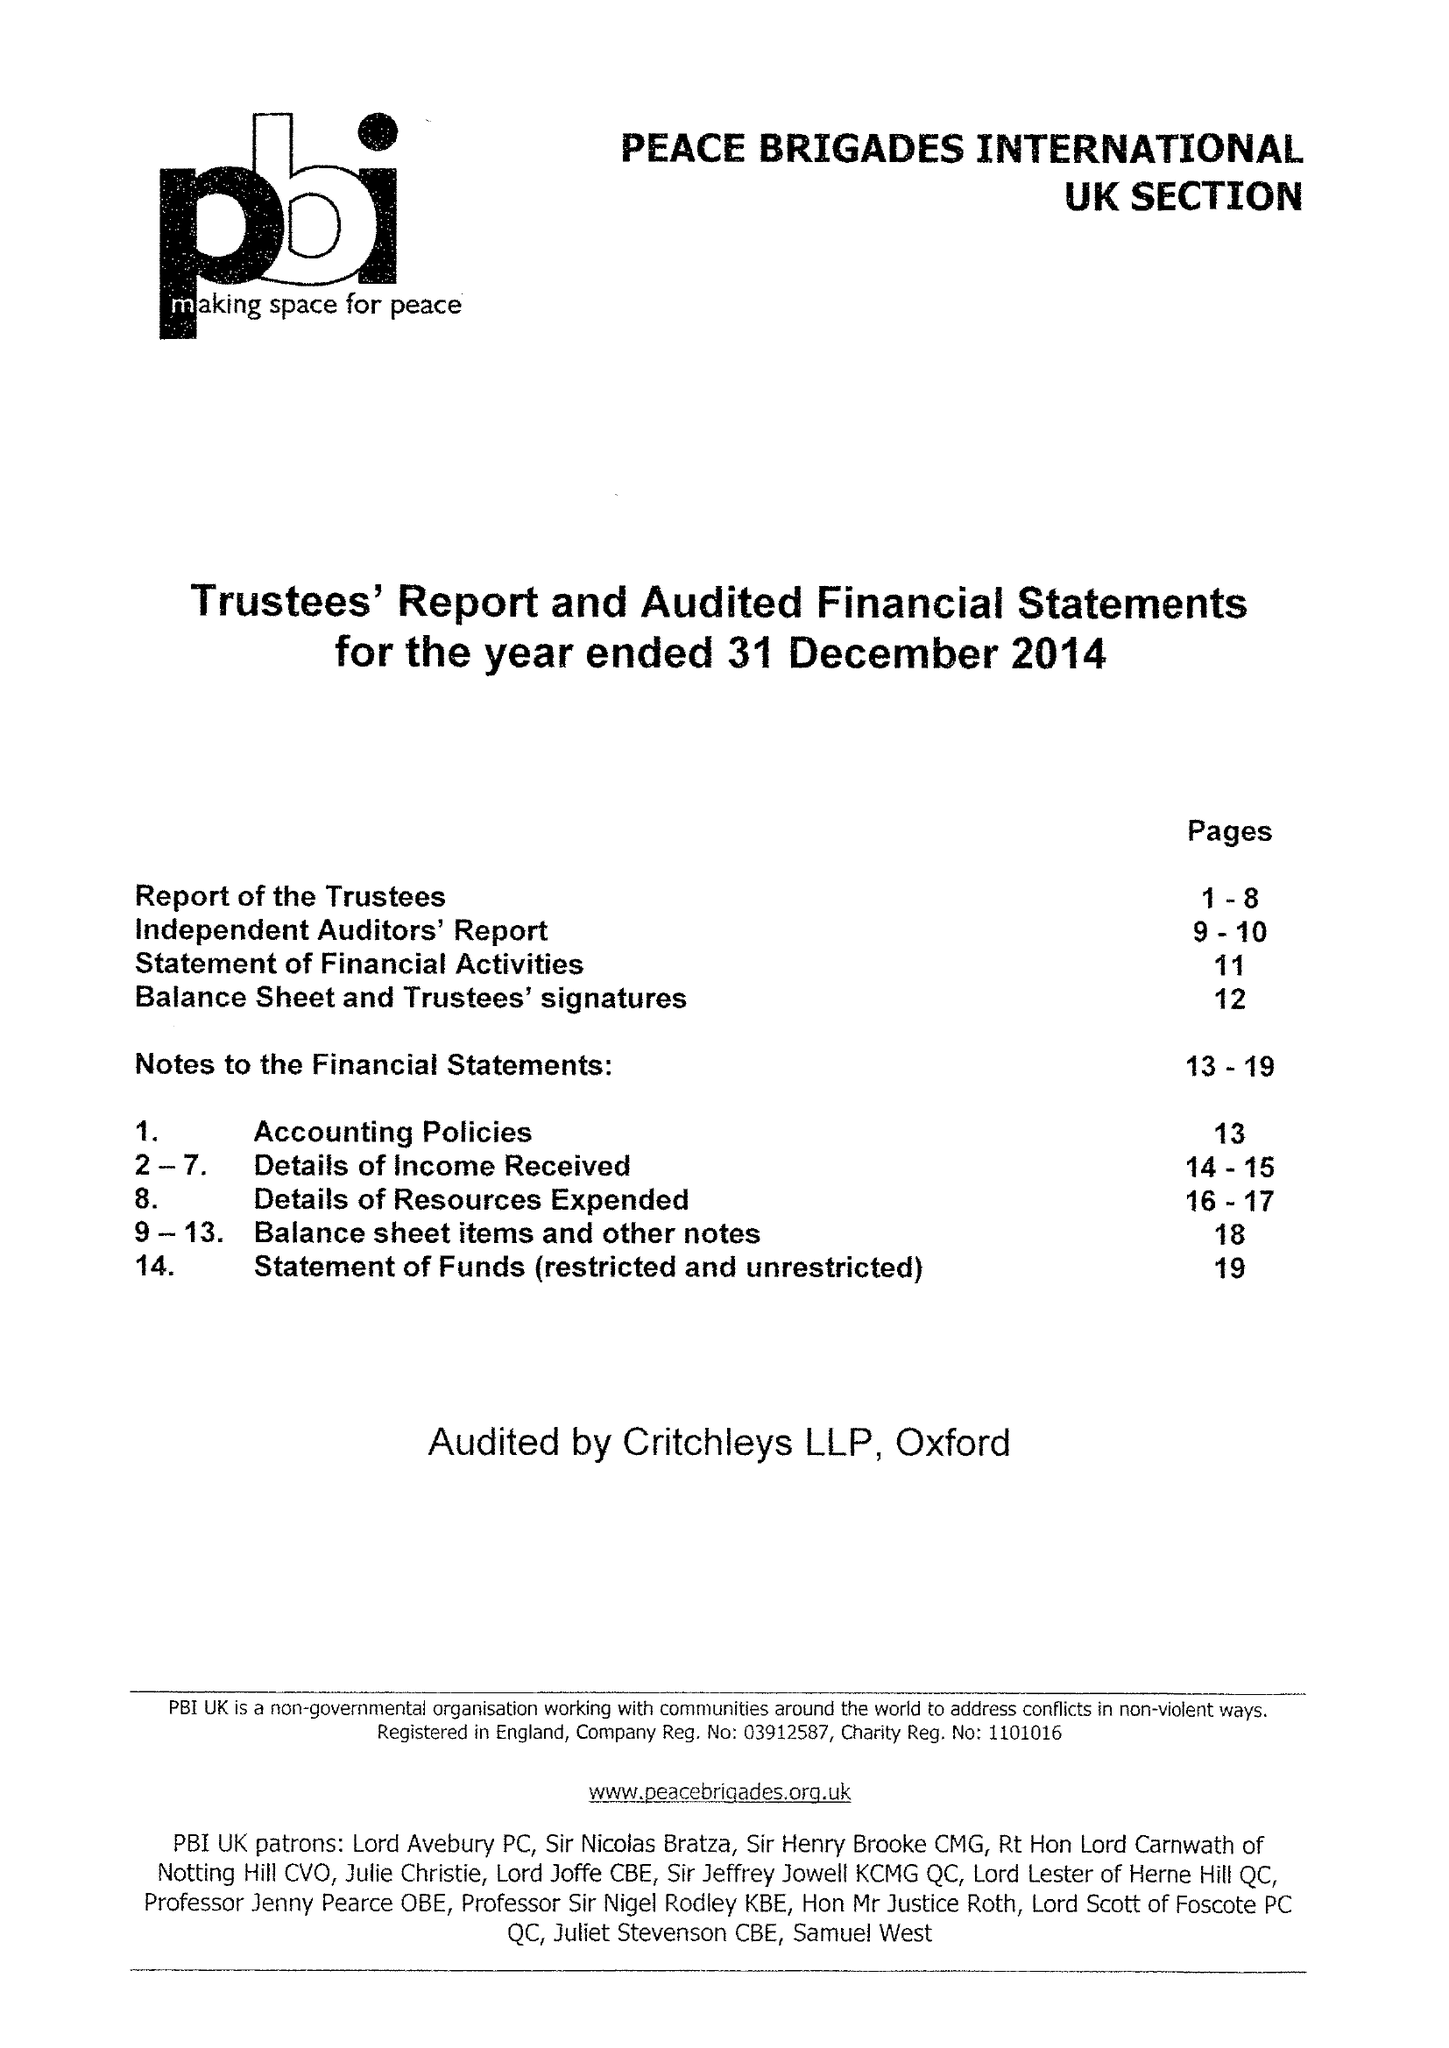What is the value for the address__post_town?
Answer the question using a single word or phrase. LONDON 